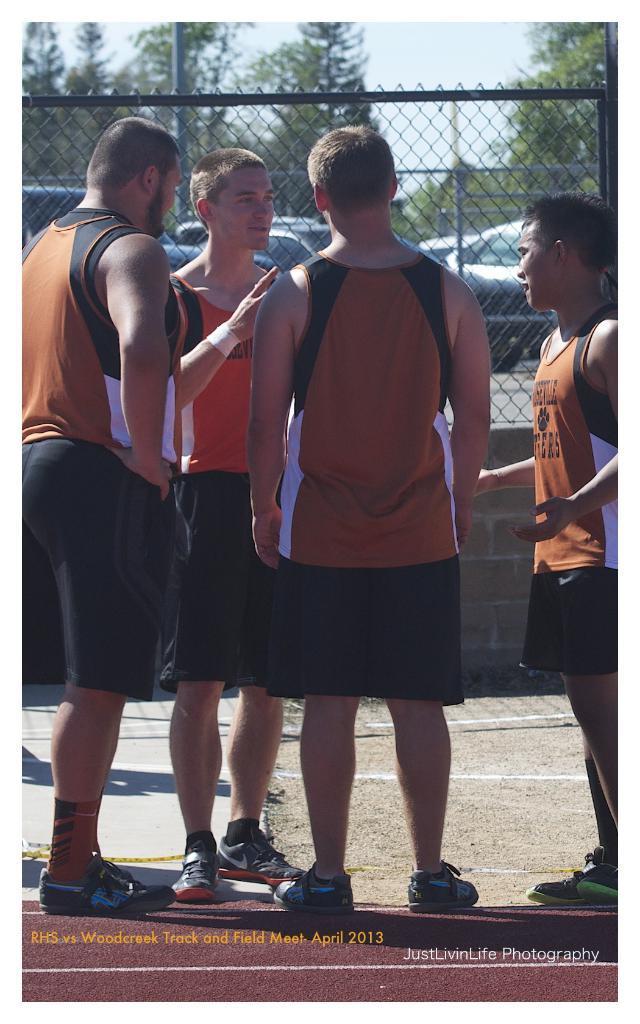Could you give a brief overview of what you see in this image? In this image we can see a group of men standing on the ground. On the backside we can see a metal fence, a group of cars on the ground, a pole, a group of trees and the sky which looks cloudy. 